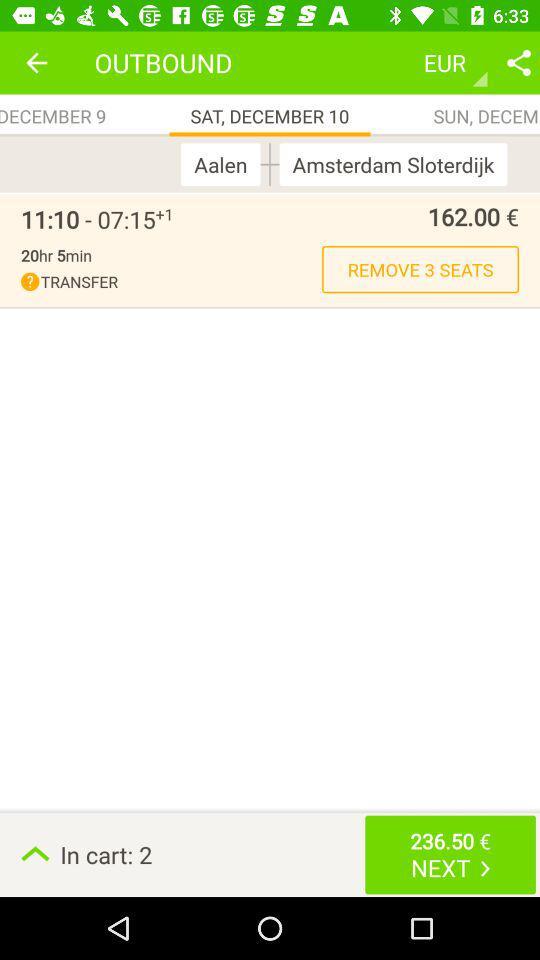What is the selected currency? The selected currency is "EUR". 